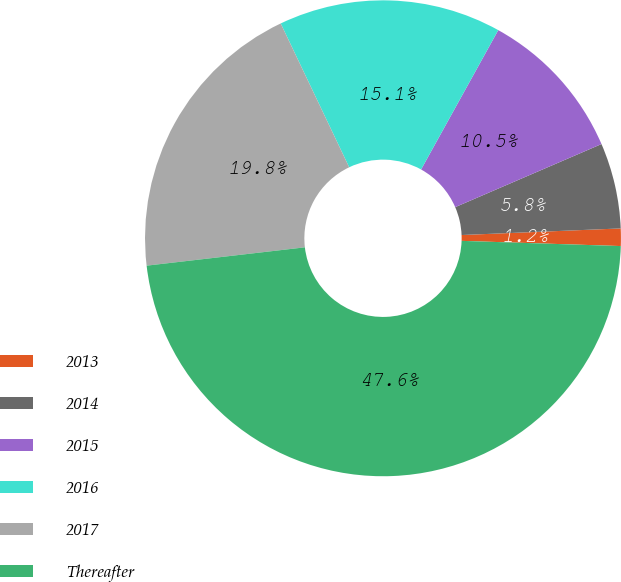<chart> <loc_0><loc_0><loc_500><loc_500><pie_chart><fcel>2013<fcel>2014<fcel>2015<fcel>2016<fcel>2017<fcel>Thereafter<nl><fcel>1.18%<fcel>5.82%<fcel>10.47%<fcel>15.12%<fcel>19.76%<fcel>47.64%<nl></chart> 